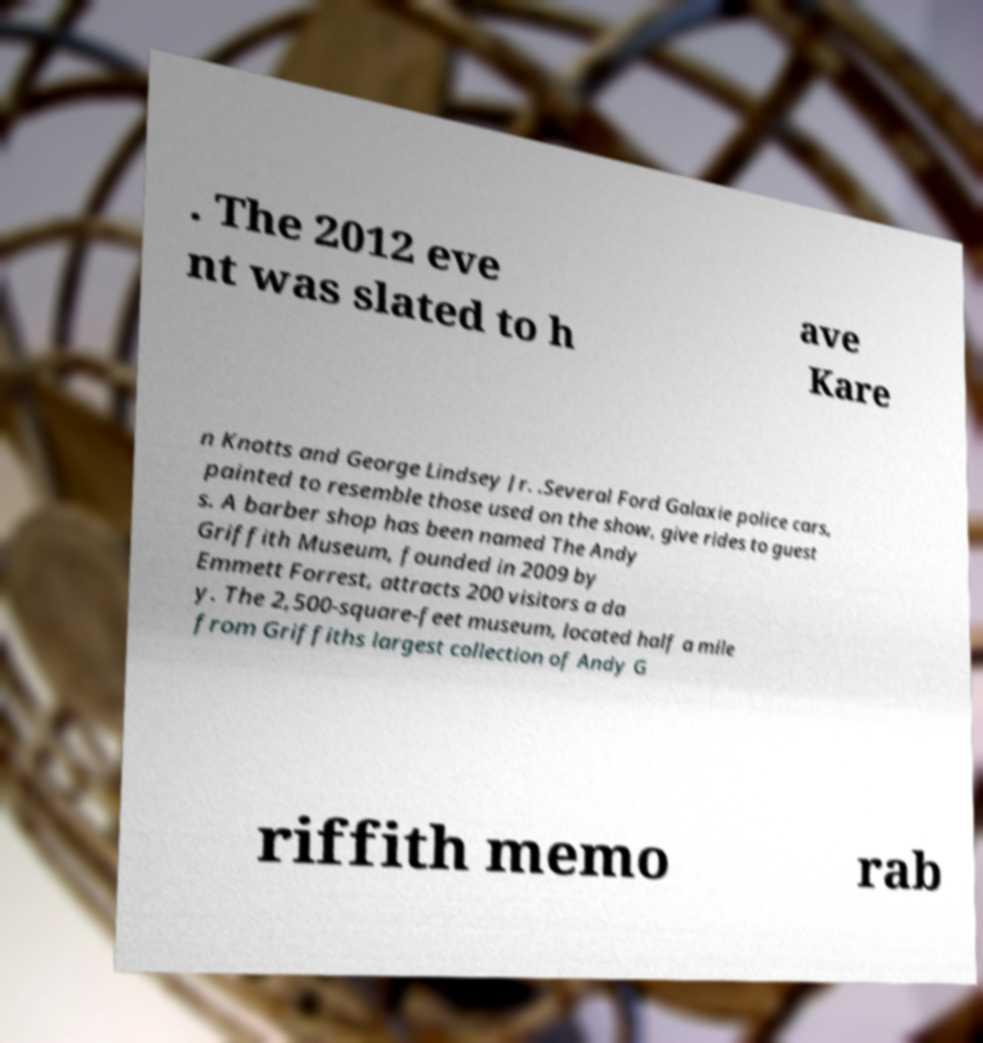For documentation purposes, I need the text within this image transcribed. Could you provide that? . The 2012 eve nt was slated to h ave Kare n Knotts and George Lindsey Jr. .Several Ford Galaxie police cars, painted to resemble those used on the show, give rides to guest s. A barber shop has been named The Andy Griffith Museum, founded in 2009 by Emmett Forrest, attracts 200 visitors a da y. The 2,500-square-feet museum, located half a mile from Griffiths largest collection of Andy G riffith memo rab 